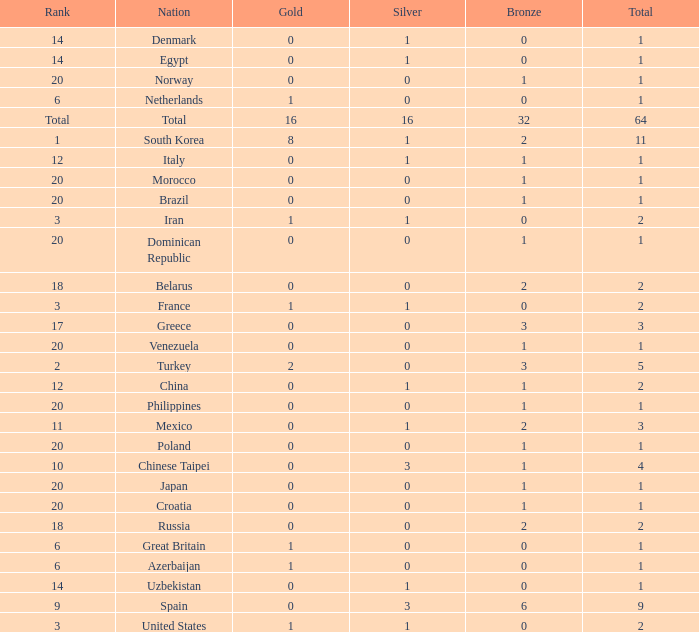How many total silvers does Russia have? 1.0. 